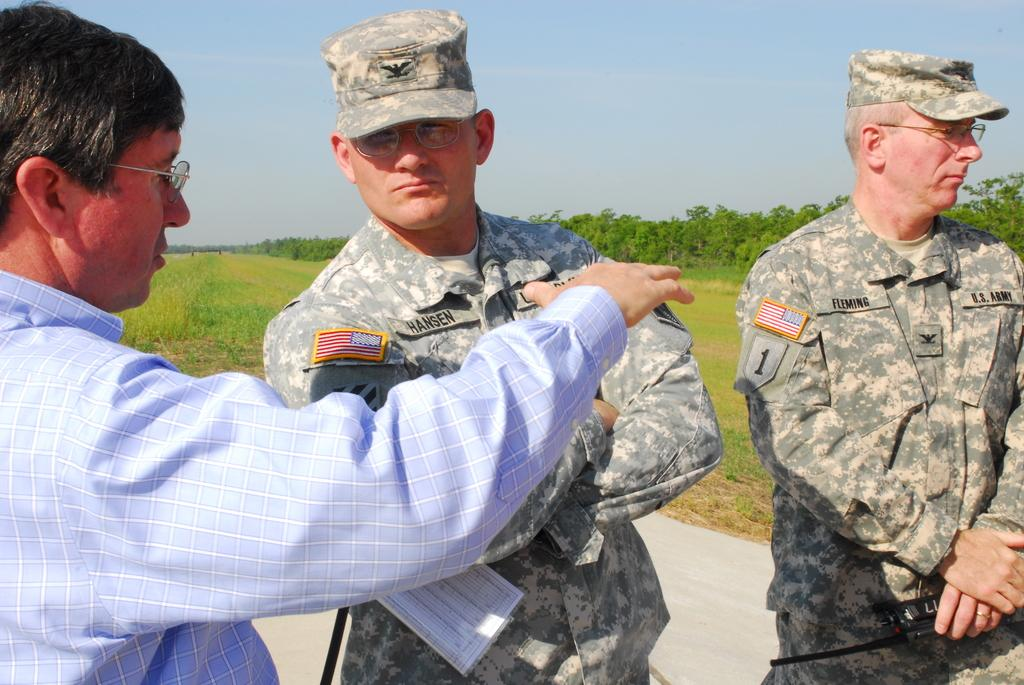How many men are present in the image? There are three men standing in the image. What do all three men have in common? All three men are wearing glasses. What is one of the men doing in the image? One of the men is holding an object. What can be seen in the background of the image? There is grass, trees, and the sky visible in the background of the image. What type of curtain can be seen hanging from the trees in the image? There are no curtains present in the image; it features three men wearing glasses and a background with grass, trees, and the sky. What kind of toys are the men playing with in the image? There are no toys visible in the image; the men are not engaged in any playful activities. 